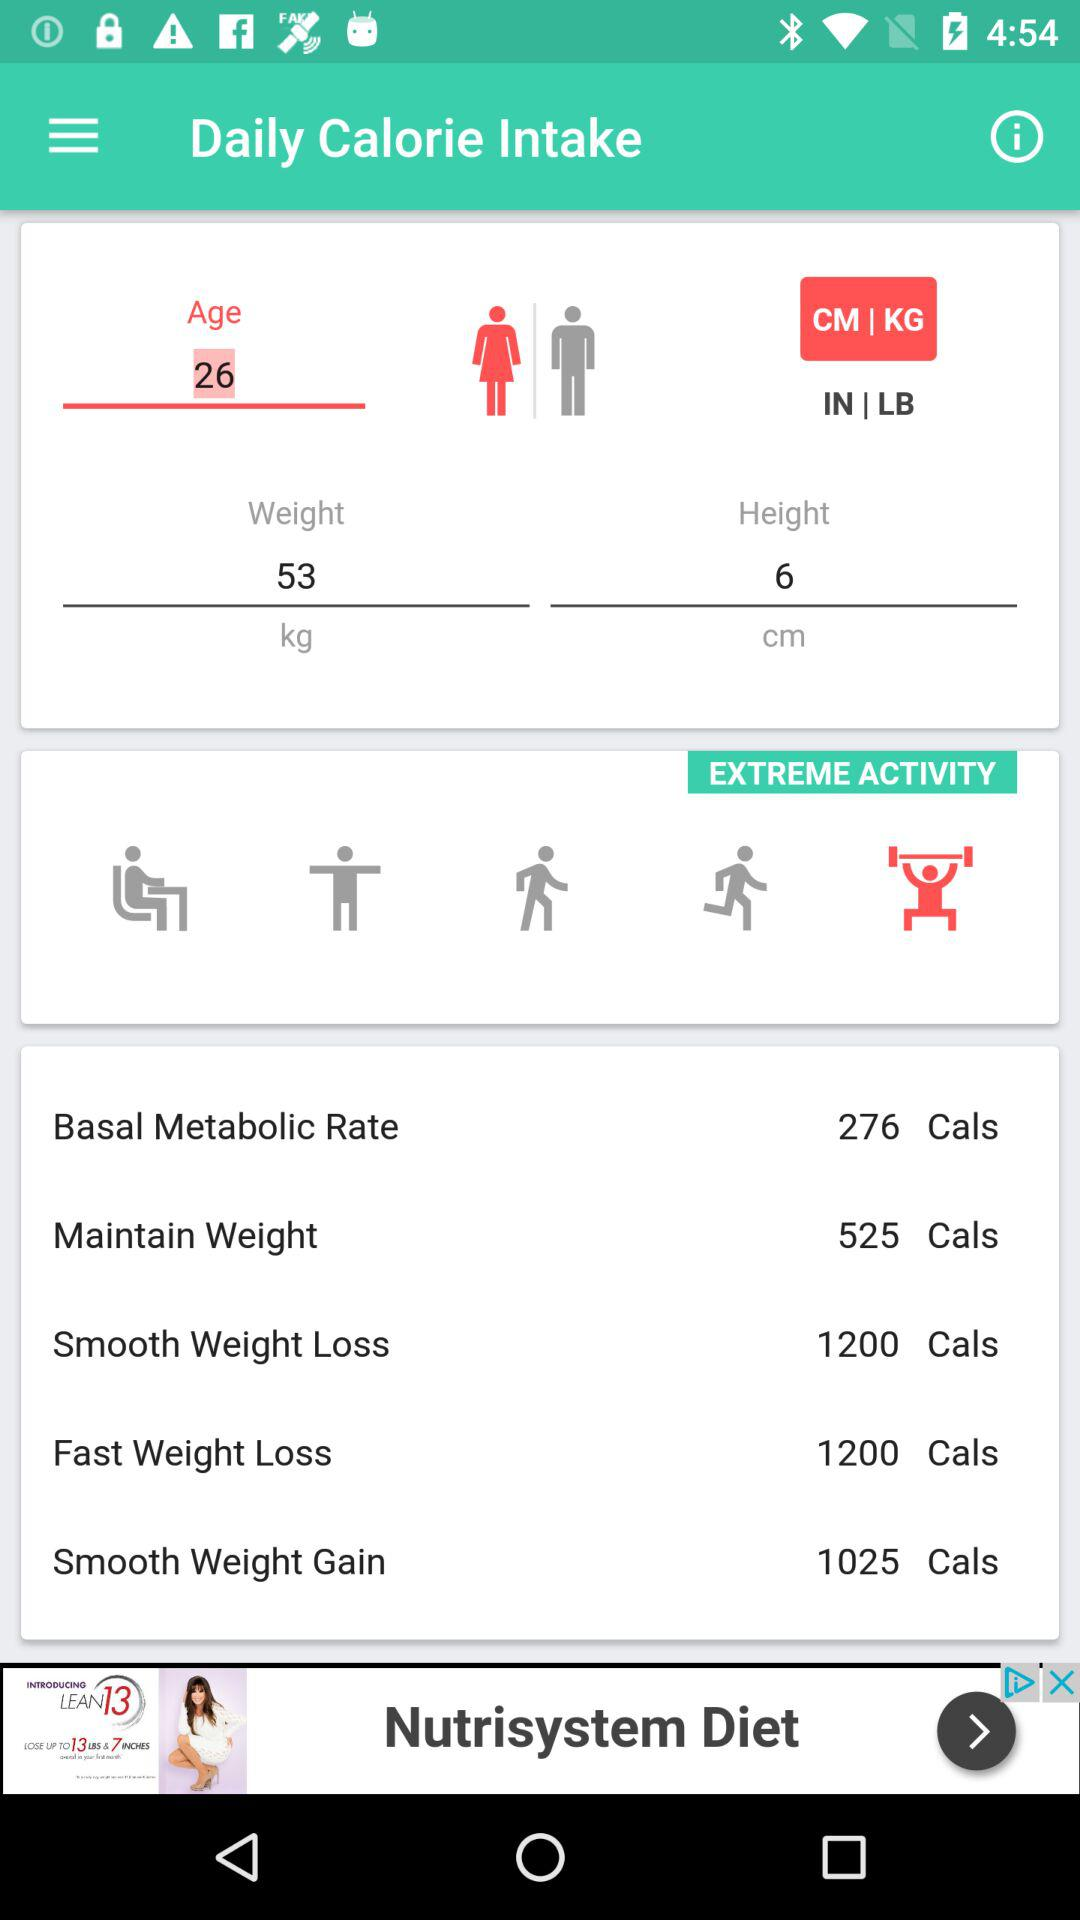What is the weight? The weight is 53 kg. 